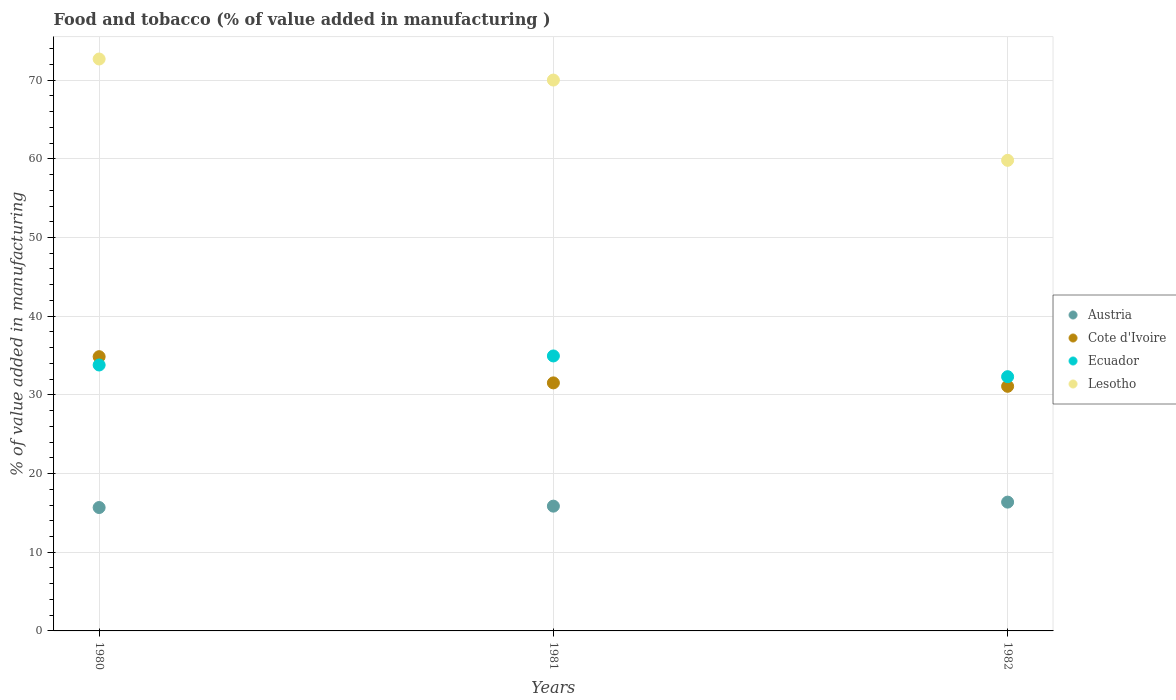What is the value added in manufacturing food and tobacco in Ecuador in 1982?
Your answer should be very brief. 32.31. Across all years, what is the maximum value added in manufacturing food and tobacco in Ecuador?
Keep it short and to the point. 34.94. Across all years, what is the minimum value added in manufacturing food and tobacco in Ecuador?
Offer a terse response. 32.31. What is the total value added in manufacturing food and tobacco in Cote d'Ivoire in the graph?
Your response must be concise. 97.46. What is the difference between the value added in manufacturing food and tobacco in Ecuador in 1981 and that in 1982?
Ensure brevity in your answer.  2.64. What is the difference between the value added in manufacturing food and tobacco in Cote d'Ivoire in 1980 and the value added in manufacturing food and tobacco in Lesotho in 1982?
Offer a terse response. -24.95. What is the average value added in manufacturing food and tobacco in Austria per year?
Your answer should be very brief. 15.97. In the year 1980, what is the difference between the value added in manufacturing food and tobacco in Austria and value added in manufacturing food and tobacco in Lesotho?
Provide a succinct answer. -57. In how many years, is the value added in manufacturing food and tobacco in Cote d'Ivoire greater than 28 %?
Ensure brevity in your answer.  3. What is the ratio of the value added in manufacturing food and tobacco in Austria in 1980 to that in 1982?
Your answer should be very brief. 0.96. Is the value added in manufacturing food and tobacco in Austria in 1981 less than that in 1982?
Provide a succinct answer. Yes. What is the difference between the highest and the second highest value added in manufacturing food and tobacco in Cote d'Ivoire?
Keep it short and to the point. 3.33. What is the difference between the highest and the lowest value added in manufacturing food and tobacco in Austria?
Make the answer very short. 0.69. How many dotlines are there?
Your answer should be very brief. 4. How many years are there in the graph?
Give a very brief answer. 3. What is the difference between two consecutive major ticks on the Y-axis?
Your answer should be compact. 10. Does the graph contain any zero values?
Make the answer very short. No. Does the graph contain grids?
Your response must be concise. Yes. Where does the legend appear in the graph?
Your response must be concise. Center right. What is the title of the graph?
Your response must be concise. Food and tobacco (% of value added in manufacturing ). What is the label or title of the Y-axis?
Provide a succinct answer. % of value added in manufacturing. What is the % of value added in manufacturing of Austria in 1980?
Ensure brevity in your answer.  15.68. What is the % of value added in manufacturing in Cote d'Ivoire in 1980?
Provide a succinct answer. 34.85. What is the % of value added in manufacturing in Ecuador in 1980?
Your response must be concise. 33.8. What is the % of value added in manufacturing of Lesotho in 1980?
Keep it short and to the point. 72.68. What is the % of value added in manufacturing of Austria in 1981?
Offer a terse response. 15.86. What is the % of value added in manufacturing of Cote d'Ivoire in 1981?
Keep it short and to the point. 31.52. What is the % of value added in manufacturing in Ecuador in 1981?
Make the answer very short. 34.94. What is the % of value added in manufacturing in Lesotho in 1981?
Keep it short and to the point. 70.01. What is the % of value added in manufacturing in Austria in 1982?
Keep it short and to the point. 16.37. What is the % of value added in manufacturing in Cote d'Ivoire in 1982?
Give a very brief answer. 31.09. What is the % of value added in manufacturing in Ecuador in 1982?
Offer a terse response. 32.31. What is the % of value added in manufacturing of Lesotho in 1982?
Your answer should be very brief. 59.81. Across all years, what is the maximum % of value added in manufacturing of Austria?
Offer a terse response. 16.37. Across all years, what is the maximum % of value added in manufacturing in Cote d'Ivoire?
Provide a succinct answer. 34.85. Across all years, what is the maximum % of value added in manufacturing in Ecuador?
Provide a succinct answer. 34.94. Across all years, what is the maximum % of value added in manufacturing in Lesotho?
Offer a very short reply. 72.68. Across all years, what is the minimum % of value added in manufacturing of Austria?
Give a very brief answer. 15.68. Across all years, what is the minimum % of value added in manufacturing of Cote d'Ivoire?
Provide a short and direct response. 31.09. Across all years, what is the minimum % of value added in manufacturing of Ecuador?
Give a very brief answer. 32.31. Across all years, what is the minimum % of value added in manufacturing of Lesotho?
Provide a short and direct response. 59.81. What is the total % of value added in manufacturing in Austria in the graph?
Provide a short and direct response. 47.91. What is the total % of value added in manufacturing of Cote d'Ivoire in the graph?
Provide a short and direct response. 97.46. What is the total % of value added in manufacturing of Ecuador in the graph?
Ensure brevity in your answer.  101.05. What is the total % of value added in manufacturing in Lesotho in the graph?
Your answer should be compact. 202.5. What is the difference between the % of value added in manufacturing in Austria in 1980 and that in 1981?
Your answer should be very brief. -0.18. What is the difference between the % of value added in manufacturing of Cote d'Ivoire in 1980 and that in 1981?
Make the answer very short. 3.33. What is the difference between the % of value added in manufacturing of Ecuador in 1980 and that in 1981?
Provide a succinct answer. -1.15. What is the difference between the % of value added in manufacturing in Lesotho in 1980 and that in 1981?
Your answer should be compact. 2.68. What is the difference between the % of value added in manufacturing of Austria in 1980 and that in 1982?
Offer a very short reply. -0.69. What is the difference between the % of value added in manufacturing in Cote d'Ivoire in 1980 and that in 1982?
Ensure brevity in your answer.  3.76. What is the difference between the % of value added in manufacturing of Ecuador in 1980 and that in 1982?
Provide a succinct answer. 1.49. What is the difference between the % of value added in manufacturing in Lesotho in 1980 and that in 1982?
Ensure brevity in your answer.  12.88. What is the difference between the % of value added in manufacturing of Austria in 1981 and that in 1982?
Make the answer very short. -0.51. What is the difference between the % of value added in manufacturing of Cote d'Ivoire in 1981 and that in 1982?
Your answer should be very brief. 0.43. What is the difference between the % of value added in manufacturing in Ecuador in 1981 and that in 1982?
Give a very brief answer. 2.64. What is the difference between the % of value added in manufacturing of Lesotho in 1981 and that in 1982?
Offer a very short reply. 10.2. What is the difference between the % of value added in manufacturing of Austria in 1980 and the % of value added in manufacturing of Cote d'Ivoire in 1981?
Your answer should be very brief. -15.84. What is the difference between the % of value added in manufacturing in Austria in 1980 and the % of value added in manufacturing in Ecuador in 1981?
Make the answer very short. -19.26. What is the difference between the % of value added in manufacturing in Austria in 1980 and the % of value added in manufacturing in Lesotho in 1981?
Make the answer very short. -54.33. What is the difference between the % of value added in manufacturing in Cote d'Ivoire in 1980 and the % of value added in manufacturing in Ecuador in 1981?
Offer a very short reply. -0.09. What is the difference between the % of value added in manufacturing in Cote d'Ivoire in 1980 and the % of value added in manufacturing in Lesotho in 1981?
Provide a succinct answer. -35.15. What is the difference between the % of value added in manufacturing of Ecuador in 1980 and the % of value added in manufacturing of Lesotho in 1981?
Ensure brevity in your answer.  -36.21. What is the difference between the % of value added in manufacturing in Austria in 1980 and the % of value added in manufacturing in Cote d'Ivoire in 1982?
Provide a short and direct response. -15.41. What is the difference between the % of value added in manufacturing in Austria in 1980 and the % of value added in manufacturing in Ecuador in 1982?
Your answer should be compact. -16.63. What is the difference between the % of value added in manufacturing of Austria in 1980 and the % of value added in manufacturing of Lesotho in 1982?
Your answer should be compact. -44.12. What is the difference between the % of value added in manufacturing of Cote d'Ivoire in 1980 and the % of value added in manufacturing of Ecuador in 1982?
Offer a very short reply. 2.54. What is the difference between the % of value added in manufacturing of Cote d'Ivoire in 1980 and the % of value added in manufacturing of Lesotho in 1982?
Offer a terse response. -24.95. What is the difference between the % of value added in manufacturing of Ecuador in 1980 and the % of value added in manufacturing of Lesotho in 1982?
Your answer should be compact. -26.01. What is the difference between the % of value added in manufacturing of Austria in 1981 and the % of value added in manufacturing of Cote d'Ivoire in 1982?
Give a very brief answer. -15.23. What is the difference between the % of value added in manufacturing in Austria in 1981 and the % of value added in manufacturing in Ecuador in 1982?
Your answer should be compact. -16.45. What is the difference between the % of value added in manufacturing in Austria in 1981 and the % of value added in manufacturing in Lesotho in 1982?
Your response must be concise. -43.95. What is the difference between the % of value added in manufacturing of Cote d'Ivoire in 1981 and the % of value added in manufacturing of Ecuador in 1982?
Offer a very short reply. -0.79. What is the difference between the % of value added in manufacturing in Cote d'Ivoire in 1981 and the % of value added in manufacturing in Lesotho in 1982?
Provide a short and direct response. -28.28. What is the difference between the % of value added in manufacturing of Ecuador in 1981 and the % of value added in manufacturing of Lesotho in 1982?
Give a very brief answer. -24.86. What is the average % of value added in manufacturing of Austria per year?
Your answer should be compact. 15.97. What is the average % of value added in manufacturing of Cote d'Ivoire per year?
Ensure brevity in your answer.  32.49. What is the average % of value added in manufacturing in Ecuador per year?
Offer a terse response. 33.68. What is the average % of value added in manufacturing of Lesotho per year?
Offer a terse response. 67.5. In the year 1980, what is the difference between the % of value added in manufacturing of Austria and % of value added in manufacturing of Cote d'Ivoire?
Give a very brief answer. -19.17. In the year 1980, what is the difference between the % of value added in manufacturing in Austria and % of value added in manufacturing in Ecuador?
Keep it short and to the point. -18.11. In the year 1980, what is the difference between the % of value added in manufacturing in Austria and % of value added in manufacturing in Lesotho?
Offer a very short reply. -57. In the year 1980, what is the difference between the % of value added in manufacturing of Cote d'Ivoire and % of value added in manufacturing of Ecuador?
Provide a succinct answer. 1.06. In the year 1980, what is the difference between the % of value added in manufacturing in Cote d'Ivoire and % of value added in manufacturing in Lesotho?
Ensure brevity in your answer.  -37.83. In the year 1980, what is the difference between the % of value added in manufacturing of Ecuador and % of value added in manufacturing of Lesotho?
Your answer should be very brief. -38.89. In the year 1981, what is the difference between the % of value added in manufacturing in Austria and % of value added in manufacturing in Cote d'Ivoire?
Offer a terse response. -15.66. In the year 1981, what is the difference between the % of value added in manufacturing in Austria and % of value added in manufacturing in Ecuador?
Your answer should be compact. -19.09. In the year 1981, what is the difference between the % of value added in manufacturing in Austria and % of value added in manufacturing in Lesotho?
Your answer should be very brief. -54.15. In the year 1981, what is the difference between the % of value added in manufacturing in Cote d'Ivoire and % of value added in manufacturing in Ecuador?
Your answer should be very brief. -3.42. In the year 1981, what is the difference between the % of value added in manufacturing in Cote d'Ivoire and % of value added in manufacturing in Lesotho?
Your answer should be very brief. -38.49. In the year 1981, what is the difference between the % of value added in manufacturing in Ecuador and % of value added in manufacturing in Lesotho?
Provide a succinct answer. -35.06. In the year 1982, what is the difference between the % of value added in manufacturing in Austria and % of value added in manufacturing in Cote d'Ivoire?
Ensure brevity in your answer.  -14.72. In the year 1982, what is the difference between the % of value added in manufacturing of Austria and % of value added in manufacturing of Ecuador?
Provide a short and direct response. -15.94. In the year 1982, what is the difference between the % of value added in manufacturing in Austria and % of value added in manufacturing in Lesotho?
Offer a very short reply. -43.44. In the year 1982, what is the difference between the % of value added in manufacturing in Cote d'Ivoire and % of value added in manufacturing in Ecuador?
Your answer should be very brief. -1.22. In the year 1982, what is the difference between the % of value added in manufacturing of Cote d'Ivoire and % of value added in manufacturing of Lesotho?
Your response must be concise. -28.72. In the year 1982, what is the difference between the % of value added in manufacturing in Ecuador and % of value added in manufacturing in Lesotho?
Keep it short and to the point. -27.5. What is the ratio of the % of value added in manufacturing of Austria in 1980 to that in 1981?
Provide a short and direct response. 0.99. What is the ratio of the % of value added in manufacturing in Cote d'Ivoire in 1980 to that in 1981?
Offer a very short reply. 1.11. What is the ratio of the % of value added in manufacturing of Ecuador in 1980 to that in 1981?
Ensure brevity in your answer.  0.97. What is the ratio of the % of value added in manufacturing of Lesotho in 1980 to that in 1981?
Ensure brevity in your answer.  1.04. What is the ratio of the % of value added in manufacturing in Austria in 1980 to that in 1982?
Offer a terse response. 0.96. What is the ratio of the % of value added in manufacturing in Cote d'Ivoire in 1980 to that in 1982?
Keep it short and to the point. 1.12. What is the ratio of the % of value added in manufacturing of Ecuador in 1980 to that in 1982?
Your answer should be very brief. 1.05. What is the ratio of the % of value added in manufacturing of Lesotho in 1980 to that in 1982?
Ensure brevity in your answer.  1.22. What is the ratio of the % of value added in manufacturing in Austria in 1981 to that in 1982?
Offer a very short reply. 0.97. What is the ratio of the % of value added in manufacturing of Cote d'Ivoire in 1981 to that in 1982?
Ensure brevity in your answer.  1.01. What is the ratio of the % of value added in manufacturing in Ecuador in 1981 to that in 1982?
Your response must be concise. 1.08. What is the ratio of the % of value added in manufacturing in Lesotho in 1981 to that in 1982?
Your answer should be compact. 1.17. What is the difference between the highest and the second highest % of value added in manufacturing in Austria?
Give a very brief answer. 0.51. What is the difference between the highest and the second highest % of value added in manufacturing in Cote d'Ivoire?
Ensure brevity in your answer.  3.33. What is the difference between the highest and the second highest % of value added in manufacturing of Ecuador?
Your response must be concise. 1.15. What is the difference between the highest and the second highest % of value added in manufacturing in Lesotho?
Your response must be concise. 2.68. What is the difference between the highest and the lowest % of value added in manufacturing in Austria?
Offer a very short reply. 0.69. What is the difference between the highest and the lowest % of value added in manufacturing in Cote d'Ivoire?
Provide a short and direct response. 3.76. What is the difference between the highest and the lowest % of value added in manufacturing in Ecuador?
Offer a terse response. 2.64. What is the difference between the highest and the lowest % of value added in manufacturing in Lesotho?
Provide a succinct answer. 12.88. 